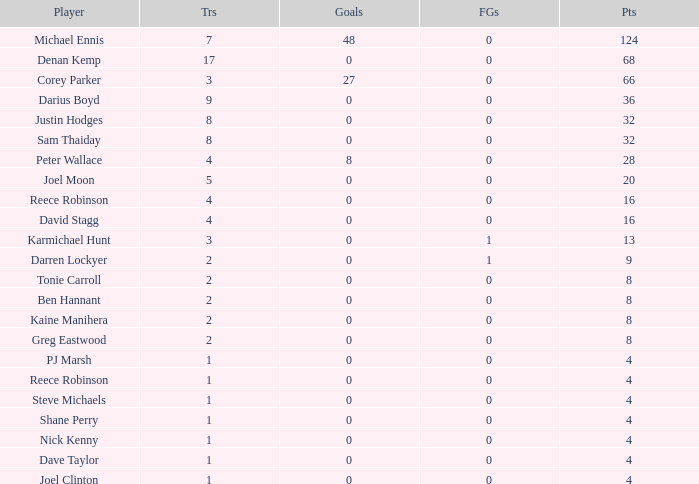What is the lowest tries the player with more than 0 goals, 28 points, and more than 0 field goals have? None. 